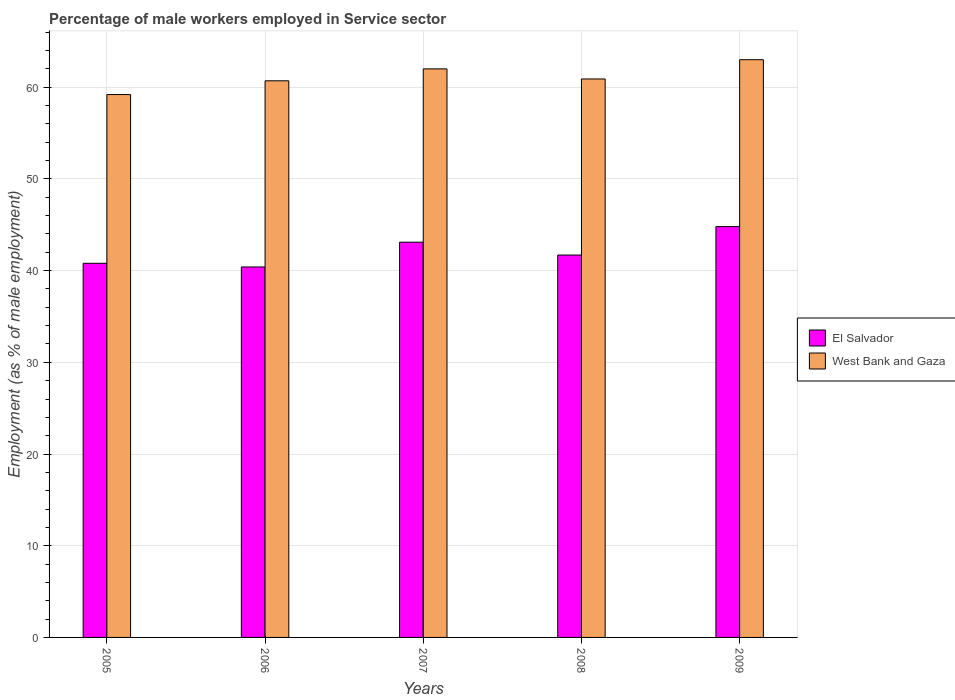How many different coloured bars are there?
Keep it short and to the point. 2. What is the label of the 5th group of bars from the left?
Make the answer very short. 2009. What is the percentage of male workers employed in Service sector in El Salvador in 2009?
Ensure brevity in your answer.  44.8. Across all years, what is the maximum percentage of male workers employed in Service sector in West Bank and Gaza?
Keep it short and to the point. 63. Across all years, what is the minimum percentage of male workers employed in Service sector in West Bank and Gaza?
Your answer should be compact. 59.2. What is the total percentage of male workers employed in Service sector in El Salvador in the graph?
Offer a terse response. 210.8. What is the difference between the percentage of male workers employed in Service sector in El Salvador in 2005 and that in 2007?
Ensure brevity in your answer.  -2.3. What is the difference between the percentage of male workers employed in Service sector in El Salvador in 2007 and the percentage of male workers employed in Service sector in West Bank and Gaza in 2008?
Provide a short and direct response. -17.8. What is the average percentage of male workers employed in Service sector in West Bank and Gaza per year?
Your response must be concise. 61.16. In the year 2009, what is the difference between the percentage of male workers employed in Service sector in West Bank and Gaza and percentage of male workers employed in Service sector in El Salvador?
Your answer should be compact. 18.2. What is the ratio of the percentage of male workers employed in Service sector in West Bank and Gaza in 2005 to that in 2008?
Ensure brevity in your answer.  0.97. Is the percentage of male workers employed in Service sector in El Salvador in 2007 less than that in 2008?
Your answer should be compact. No. What is the difference between the highest and the second highest percentage of male workers employed in Service sector in West Bank and Gaza?
Provide a succinct answer. 1. What is the difference between the highest and the lowest percentage of male workers employed in Service sector in El Salvador?
Give a very brief answer. 4.4. In how many years, is the percentage of male workers employed in Service sector in West Bank and Gaza greater than the average percentage of male workers employed in Service sector in West Bank and Gaza taken over all years?
Offer a terse response. 2. What does the 1st bar from the left in 2008 represents?
Your answer should be compact. El Salvador. What does the 1st bar from the right in 2006 represents?
Make the answer very short. West Bank and Gaza. How many bars are there?
Provide a succinct answer. 10. How many years are there in the graph?
Provide a succinct answer. 5. What is the difference between two consecutive major ticks on the Y-axis?
Make the answer very short. 10. Are the values on the major ticks of Y-axis written in scientific E-notation?
Provide a short and direct response. No. Does the graph contain grids?
Make the answer very short. Yes. Where does the legend appear in the graph?
Keep it short and to the point. Center right. What is the title of the graph?
Give a very brief answer. Percentage of male workers employed in Service sector. Does "Colombia" appear as one of the legend labels in the graph?
Offer a very short reply. No. What is the label or title of the Y-axis?
Offer a very short reply. Employment (as % of male employment). What is the Employment (as % of male employment) of El Salvador in 2005?
Make the answer very short. 40.8. What is the Employment (as % of male employment) in West Bank and Gaza in 2005?
Your answer should be compact. 59.2. What is the Employment (as % of male employment) in El Salvador in 2006?
Offer a very short reply. 40.4. What is the Employment (as % of male employment) of West Bank and Gaza in 2006?
Offer a terse response. 60.7. What is the Employment (as % of male employment) in El Salvador in 2007?
Your answer should be compact. 43.1. What is the Employment (as % of male employment) of West Bank and Gaza in 2007?
Provide a short and direct response. 62. What is the Employment (as % of male employment) of El Salvador in 2008?
Your answer should be compact. 41.7. What is the Employment (as % of male employment) of West Bank and Gaza in 2008?
Make the answer very short. 60.9. What is the Employment (as % of male employment) in El Salvador in 2009?
Offer a terse response. 44.8. What is the Employment (as % of male employment) in West Bank and Gaza in 2009?
Give a very brief answer. 63. Across all years, what is the maximum Employment (as % of male employment) in El Salvador?
Your answer should be compact. 44.8. Across all years, what is the maximum Employment (as % of male employment) of West Bank and Gaza?
Your response must be concise. 63. Across all years, what is the minimum Employment (as % of male employment) in El Salvador?
Your answer should be compact. 40.4. Across all years, what is the minimum Employment (as % of male employment) in West Bank and Gaza?
Your answer should be compact. 59.2. What is the total Employment (as % of male employment) in El Salvador in the graph?
Ensure brevity in your answer.  210.8. What is the total Employment (as % of male employment) in West Bank and Gaza in the graph?
Your answer should be very brief. 305.8. What is the difference between the Employment (as % of male employment) of El Salvador in 2005 and that in 2007?
Your answer should be very brief. -2.3. What is the difference between the Employment (as % of male employment) in West Bank and Gaza in 2005 and that in 2007?
Offer a very short reply. -2.8. What is the difference between the Employment (as % of male employment) in El Salvador in 2005 and that in 2008?
Provide a short and direct response. -0.9. What is the difference between the Employment (as % of male employment) in West Bank and Gaza in 2005 and that in 2008?
Your response must be concise. -1.7. What is the difference between the Employment (as % of male employment) in El Salvador in 2005 and that in 2009?
Keep it short and to the point. -4. What is the difference between the Employment (as % of male employment) of El Salvador in 2006 and that in 2008?
Your response must be concise. -1.3. What is the difference between the Employment (as % of male employment) in El Salvador in 2006 and that in 2009?
Your answer should be compact. -4.4. What is the difference between the Employment (as % of male employment) in West Bank and Gaza in 2007 and that in 2008?
Ensure brevity in your answer.  1.1. What is the difference between the Employment (as % of male employment) of West Bank and Gaza in 2007 and that in 2009?
Offer a terse response. -1. What is the difference between the Employment (as % of male employment) in West Bank and Gaza in 2008 and that in 2009?
Give a very brief answer. -2.1. What is the difference between the Employment (as % of male employment) in El Salvador in 2005 and the Employment (as % of male employment) in West Bank and Gaza in 2006?
Give a very brief answer. -19.9. What is the difference between the Employment (as % of male employment) of El Salvador in 2005 and the Employment (as % of male employment) of West Bank and Gaza in 2007?
Your response must be concise. -21.2. What is the difference between the Employment (as % of male employment) of El Salvador in 2005 and the Employment (as % of male employment) of West Bank and Gaza in 2008?
Give a very brief answer. -20.1. What is the difference between the Employment (as % of male employment) in El Salvador in 2005 and the Employment (as % of male employment) in West Bank and Gaza in 2009?
Provide a short and direct response. -22.2. What is the difference between the Employment (as % of male employment) in El Salvador in 2006 and the Employment (as % of male employment) in West Bank and Gaza in 2007?
Provide a short and direct response. -21.6. What is the difference between the Employment (as % of male employment) in El Salvador in 2006 and the Employment (as % of male employment) in West Bank and Gaza in 2008?
Provide a short and direct response. -20.5. What is the difference between the Employment (as % of male employment) in El Salvador in 2006 and the Employment (as % of male employment) in West Bank and Gaza in 2009?
Provide a short and direct response. -22.6. What is the difference between the Employment (as % of male employment) in El Salvador in 2007 and the Employment (as % of male employment) in West Bank and Gaza in 2008?
Your answer should be compact. -17.8. What is the difference between the Employment (as % of male employment) in El Salvador in 2007 and the Employment (as % of male employment) in West Bank and Gaza in 2009?
Your answer should be compact. -19.9. What is the difference between the Employment (as % of male employment) in El Salvador in 2008 and the Employment (as % of male employment) in West Bank and Gaza in 2009?
Your answer should be very brief. -21.3. What is the average Employment (as % of male employment) of El Salvador per year?
Ensure brevity in your answer.  42.16. What is the average Employment (as % of male employment) of West Bank and Gaza per year?
Make the answer very short. 61.16. In the year 2005, what is the difference between the Employment (as % of male employment) in El Salvador and Employment (as % of male employment) in West Bank and Gaza?
Ensure brevity in your answer.  -18.4. In the year 2006, what is the difference between the Employment (as % of male employment) of El Salvador and Employment (as % of male employment) of West Bank and Gaza?
Your response must be concise. -20.3. In the year 2007, what is the difference between the Employment (as % of male employment) of El Salvador and Employment (as % of male employment) of West Bank and Gaza?
Offer a terse response. -18.9. In the year 2008, what is the difference between the Employment (as % of male employment) in El Salvador and Employment (as % of male employment) in West Bank and Gaza?
Provide a succinct answer. -19.2. In the year 2009, what is the difference between the Employment (as % of male employment) in El Salvador and Employment (as % of male employment) in West Bank and Gaza?
Keep it short and to the point. -18.2. What is the ratio of the Employment (as % of male employment) in El Salvador in 2005 to that in 2006?
Give a very brief answer. 1.01. What is the ratio of the Employment (as % of male employment) in West Bank and Gaza in 2005 to that in 2006?
Ensure brevity in your answer.  0.98. What is the ratio of the Employment (as % of male employment) of El Salvador in 2005 to that in 2007?
Ensure brevity in your answer.  0.95. What is the ratio of the Employment (as % of male employment) in West Bank and Gaza in 2005 to that in 2007?
Give a very brief answer. 0.95. What is the ratio of the Employment (as % of male employment) of El Salvador in 2005 to that in 2008?
Give a very brief answer. 0.98. What is the ratio of the Employment (as % of male employment) in West Bank and Gaza in 2005 to that in 2008?
Your answer should be very brief. 0.97. What is the ratio of the Employment (as % of male employment) of El Salvador in 2005 to that in 2009?
Offer a very short reply. 0.91. What is the ratio of the Employment (as % of male employment) in West Bank and Gaza in 2005 to that in 2009?
Your answer should be very brief. 0.94. What is the ratio of the Employment (as % of male employment) in El Salvador in 2006 to that in 2007?
Ensure brevity in your answer.  0.94. What is the ratio of the Employment (as % of male employment) of West Bank and Gaza in 2006 to that in 2007?
Provide a short and direct response. 0.98. What is the ratio of the Employment (as % of male employment) of El Salvador in 2006 to that in 2008?
Provide a succinct answer. 0.97. What is the ratio of the Employment (as % of male employment) in El Salvador in 2006 to that in 2009?
Give a very brief answer. 0.9. What is the ratio of the Employment (as % of male employment) of West Bank and Gaza in 2006 to that in 2009?
Offer a terse response. 0.96. What is the ratio of the Employment (as % of male employment) of El Salvador in 2007 to that in 2008?
Keep it short and to the point. 1.03. What is the ratio of the Employment (as % of male employment) in West Bank and Gaza in 2007 to that in 2008?
Your answer should be compact. 1.02. What is the ratio of the Employment (as % of male employment) in El Salvador in 2007 to that in 2009?
Your answer should be very brief. 0.96. What is the ratio of the Employment (as % of male employment) of West Bank and Gaza in 2007 to that in 2009?
Offer a very short reply. 0.98. What is the ratio of the Employment (as % of male employment) of El Salvador in 2008 to that in 2009?
Provide a succinct answer. 0.93. What is the ratio of the Employment (as % of male employment) of West Bank and Gaza in 2008 to that in 2009?
Keep it short and to the point. 0.97. What is the difference between the highest and the second highest Employment (as % of male employment) in West Bank and Gaza?
Ensure brevity in your answer.  1. What is the difference between the highest and the lowest Employment (as % of male employment) in West Bank and Gaza?
Ensure brevity in your answer.  3.8. 